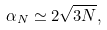<formula> <loc_0><loc_0><loc_500><loc_500>\alpha _ { N } \simeq 2 \sqrt { 3 N } ,</formula> 